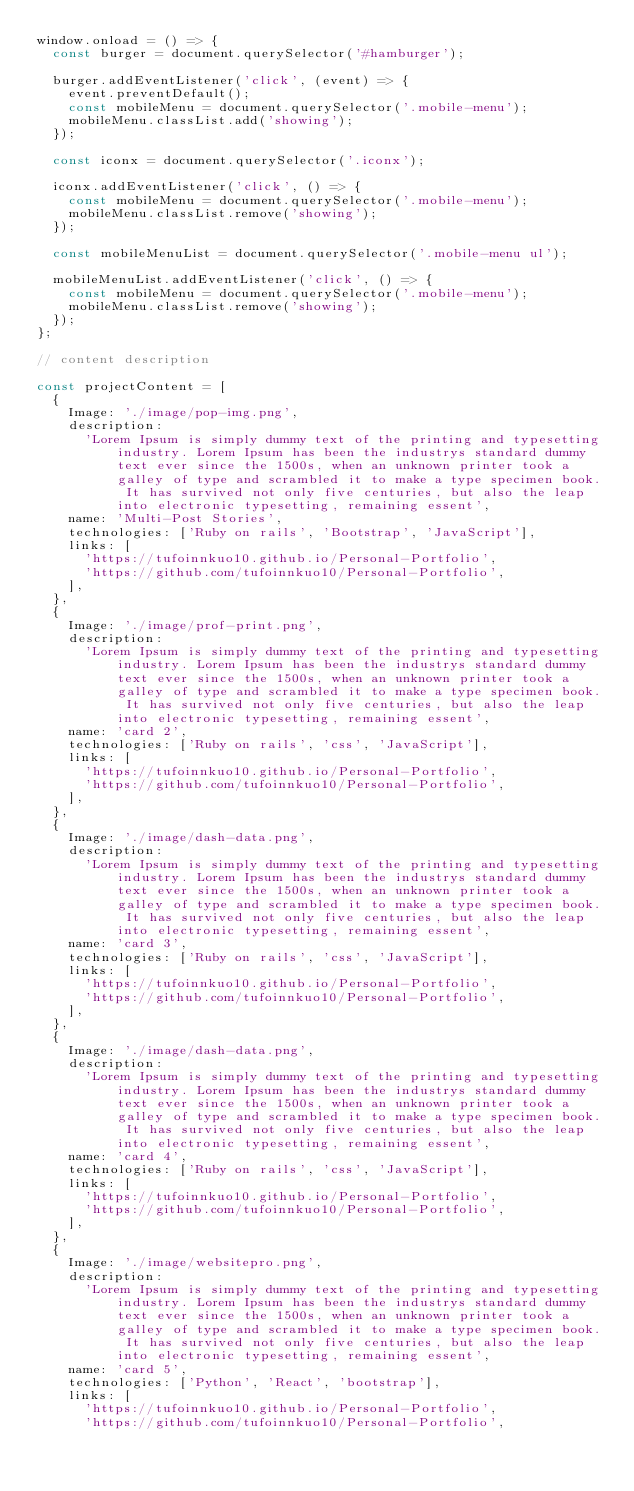<code> <loc_0><loc_0><loc_500><loc_500><_JavaScript_>window.onload = () => {
  const burger = document.querySelector('#hamburger');

  burger.addEventListener('click', (event) => {
    event.preventDefault();
    const mobileMenu = document.querySelector('.mobile-menu');
    mobileMenu.classList.add('showing');
  });

  const iconx = document.querySelector('.iconx');

  iconx.addEventListener('click', () => {
    const mobileMenu = document.querySelector('.mobile-menu');
    mobileMenu.classList.remove('showing');
  });

  const mobileMenuList = document.querySelector('.mobile-menu ul');

  mobileMenuList.addEventListener('click', () => {
    const mobileMenu = document.querySelector('.mobile-menu');
    mobileMenu.classList.remove('showing');
  });
};

// content description

const projectContent = [
  {
    Image: './image/pop-img.png',
    description:
      'Lorem Ipsum is simply dummy text of the printing and typesetting industry. Lorem Ipsum has been the industrys standard dummy text ever since the 1500s, when an unknown printer took a galley of type and scrambled it to make a type specimen book. It has survived not only five centuries, but also the leap into electronic typesetting, remaining essent',
    name: 'Multi-Post Stories',
    technologies: ['Ruby on rails', 'Bootstrap', 'JavaScript'],
    links: [
      'https://tufoinnkuo10.github.io/Personal-Portfolio',
      'https://github.com/tufoinnkuo10/Personal-Portfolio',
    ],
  },
  {
    Image: './image/prof-print.png',
    description:
      'Lorem Ipsum is simply dummy text of the printing and typesetting industry. Lorem Ipsum has been the industrys standard dummy text ever since the 1500s, when an unknown printer took a galley of type and scrambled it to make a type specimen book. It has survived not only five centuries, but also the leap into electronic typesetting, remaining essent',
    name: 'card 2',
    technologies: ['Ruby on rails', 'css', 'JavaScript'],
    links: [
      'https://tufoinnkuo10.github.io/Personal-Portfolio',
      'https://github.com/tufoinnkuo10/Personal-Portfolio',
    ],
  },
  {
    Image: './image/dash-data.png',
    description:
      'Lorem Ipsum is simply dummy text of the printing and typesetting industry. Lorem Ipsum has been the industrys standard dummy text ever since the 1500s, when an unknown printer took a galley of type and scrambled it to make a type specimen book. It has survived not only five centuries, but also the leap into electronic typesetting, remaining essent',
    name: 'card 3',
    technologies: ['Ruby on rails', 'css', 'JavaScript'],
    links: [
      'https://tufoinnkuo10.github.io/Personal-Portfolio',
      'https://github.com/tufoinnkuo10/Personal-Portfolio',
    ],
  },
  {
    Image: './image/dash-data.png',
    description:
      'Lorem Ipsum is simply dummy text of the printing and typesetting industry. Lorem Ipsum has been the industrys standard dummy text ever since the 1500s, when an unknown printer took a galley of type and scrambled it to make a type specimen book. It has survived not only five centuries, but also the leap into electronic typesetting, remaining essent',
    name: 'card 4',
    technologies: ['Ruby on rails', 'css', 'JavaScript'],
    links: [
      'https://tufoinnkuo10.github.io/Personal-Portfolio',
      'https://github.com/tufoinnkuo10/Personal-Portfolio',
    ],
  },
  {
    Image: './image/websitepro.png',
    description:
      'Lorem Ipsum is simply dummy text of the printing and typesetting industry. Lorem Ipsum has been the industrys standard dummy text ever since the 1500s, when an unknown printer took a galley of type and scrambled it to make a type specimen book. It has survived not only five centuries, but also the leap into electronic typesetting, remaining essent',
    name: 'card 5',
    technologies: ['Python', 'React', 'bootstrap'],
    links: [
      'https://tufoinnkuo10.github.io/Personal-Portfolio',
      'https://github.com/tufoinnkuo10/Personal-Portfolio',</code> 